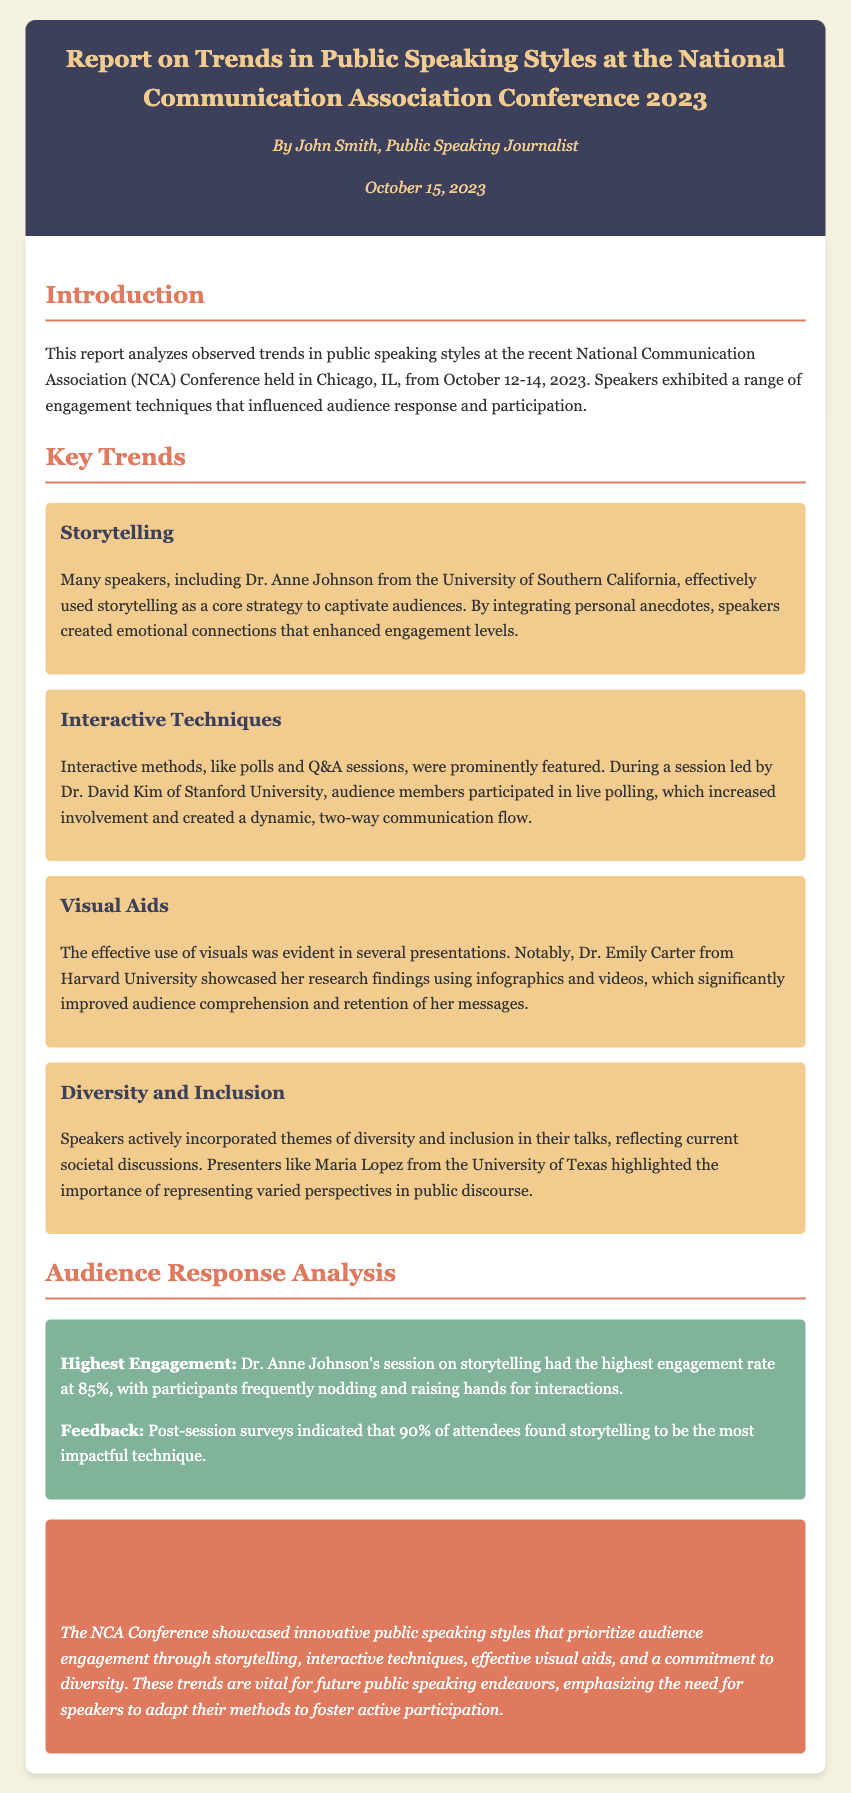What is the title of the report? The title of the report is stated in the header section of the document.
Answer: Report on Trends in Public Speaking Styles at the National Communication Association Conference 2023 Who is the author of the report? The author's name is provided in the header along with the date.
Answer: John Smith What were the dates of the conference? The dates of the conference are mentioned in the introduction section of the report.
Answer: October 12-14, 2023 Which speaker had the highest engagement rate? The engagement metrics section provides information about the speaker with the highest engagement.
Answer: Dr. Anne Johnson What was the primary technique used by Dr. Anne Johnson? The document specifies the key trend associated with Dr. Anne Johnson.
Answer: Storytelling What percentage of attendees found storytelling impactful? The feedback data in the audience response analysis section indicates the percentage of attendees.
Answer: 90% Which university did Dr. David Kim represent? The document specifies the affiliation of Dr. David Kim in the interactive techniques trend.
Answer: Stanford University What is a notable theme incorporated by speakers? The key trends section specifies a theme prominent in the presentations.
Answer: Diversity and Inclusion Which visual aid did Dr. Emily Carter effectively use? The document states the type of visual aids employed by Dr. Emily Carter.
Answer: Infographics and videos 